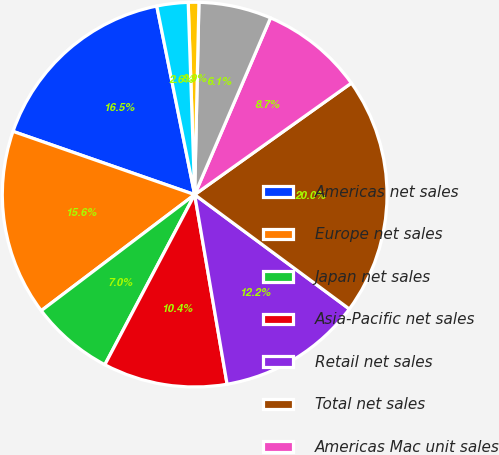<chart> <loc_0><loc_0><loc_500><loc_500><pie_chart><fcel>Americas net sales<fcel>Europe net sales<fcel>Japan net sales<fcel>Asia-Pacific net sales<fcel>Retail net sales<fcel>Total net sales<fcel>Americas Mac unit sales<fcel>Europe Mac unit sales<fcel>Japan Mac unit sales<fcel>Asia-Pacific Mac unit sales<nl><fcel>16.51%<fcel>15.64%<fcel>6.96%<fcel>10.43%<fcel>12.17%<fcel>19.98%<fcel>8.7%<fcel>6.1%<fcel>0.89%<fcel>2.62%<nl></chart> 